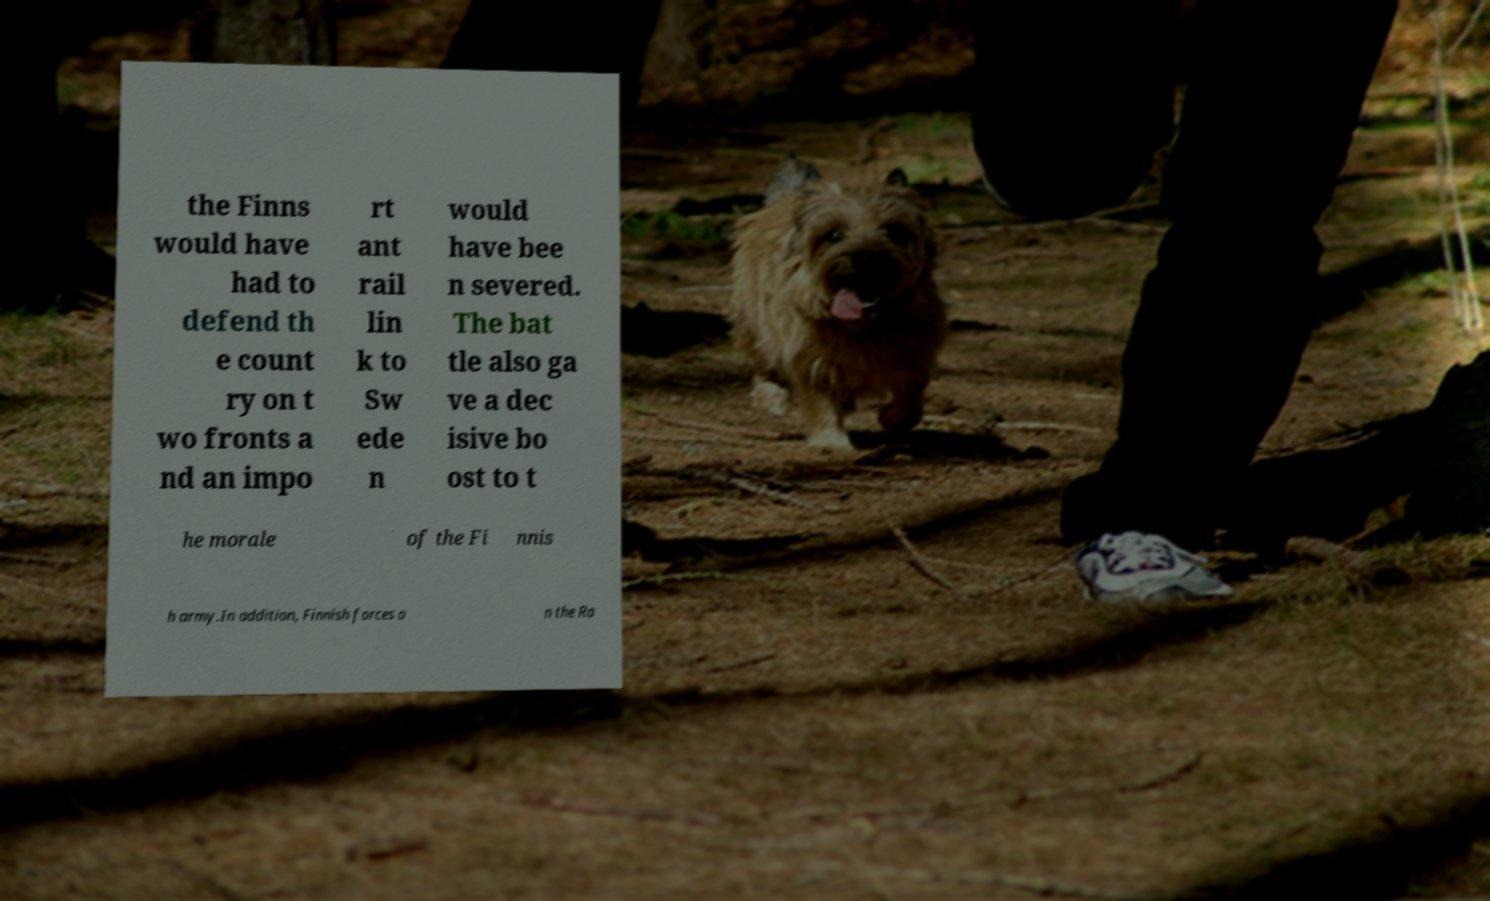For documentation purposes, I need the text within this image transcribed. Could you provide that? the Finns would have had to defend th e count ry on t wo fronts a nd an impo rt ant rail lin k to Sw ede n would have bee n severed. The bat tle also ga ve a dec isive bo ost to t he morale of the Fi nnis h army.In addition, Finnish forces o n the Ra 